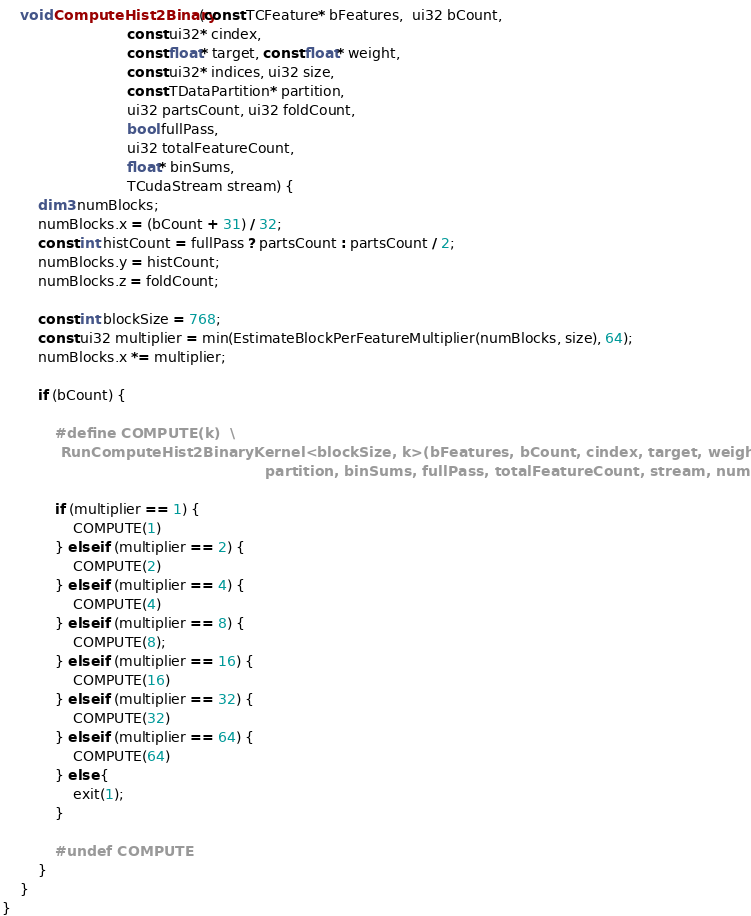<code> <loc_0><loc_0><loc_500><loc_500><_Cuda_>


    void ComputeHist2Binary(const TCFeature* bFeatures,  ui32 bCount,
                            const ui32* cindex,
                            const float* target, const float* weight,
                            const ui32* indices, ui32 size,
                            const TDataPartition* partition,
                            ui32 partsCount, ui32 foldCount,
                            bool fullPass,
                            ui32 totalFeatureCount,
                            float* binSums,
                            TCudaStream stream) {
        dim3 numBlocks;
        numBlocks.x = (bCount + 31) / 32;
        const int histCount = fullPass ? partsCount : partsCount / 2;
        numBlocks.y = histCount;
        numBlocks.z = foldCount;

        const int blockSize = 768;
        const ui32 multiplier = min(EstimateBlockPerFeatureMultiplier(numBlocks, size), 64);
        numBlocks.x *= multiplier;

        if (bCount) {

            #define COMPUTE(k)  \
            RunComputeHist2BinaryKernel<blockSize, k>(bFeatures, bCount, cindex, target, weight, indices, \
                                                      partition, binSums, fullPass, totalFeatureCount, stream, numBlocks); \

            if (multiplier == 1) {
                COMPUTE(1)
            } else if (multiplier == 2) {
                COMPUTE(2)
            } else if (multiplier == 4) {
                COMPUTE(4)
            } else if (multiplier == 8) {
                COMPUTE(8);
            } else if (multiplier == 16) {
                COMPUTE(16)
            } else if (multiplier == 32) {
                COMPUTE(32)
            } else if (multiplier == 64) {
                COMPUTE(64)
            } else {
                exit(1);
            }

            #undef COMPUTE
        }
    }
}
</code> 